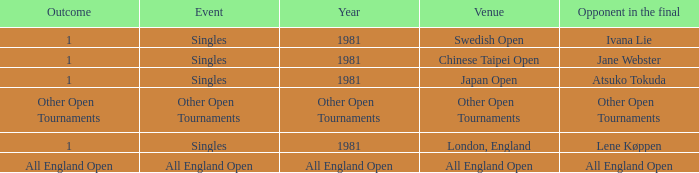Who was the Opponent in London, England with an Outcome of 1? Lene Køppen. 